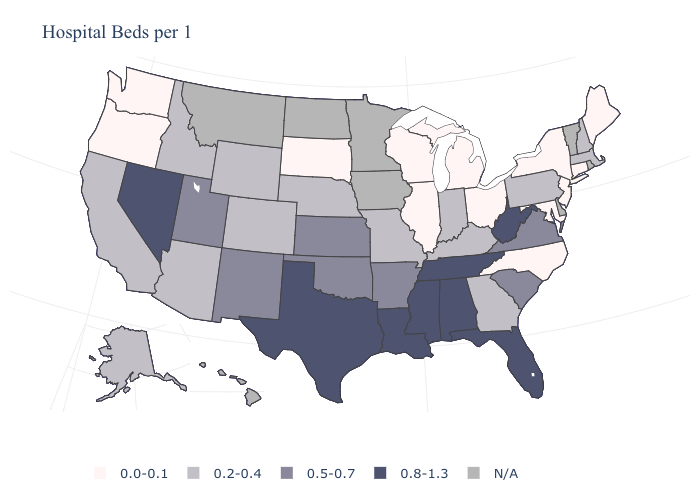What is the lowest value in the MidWest?
Keep it brief. 0.0-0.1. Name the states that have a value in the range 0.5-0.7?
Concise answer only. Arkansas, Kansas, New Mexico, Oklahoma, South Carolina, Utah, Virginia. What is the highest value in the MidWest ?
Write a very short answer. 0.5-0.7. Name the states that have a value in the range 0.0-0.1?
Give a very brief answer. Connecticut, Illinois, Maine, Maryland, Michigan, New Jersey, New York, North Carolina, Ohio, Oregon, South Dakota, Washington, Wisconsin. Which states hav the highest value in the South?
Keep it brief. Alabama, Florida, Louisiana, Mississippi, Tennessee, Texas, West Virginia. Which states have the highest value in the USA?
Short answer required. Alabama, Florida, Louisiana, Mississippi, Nevada, Tennessee, Texas, West Virginia. What is the value of Pennsylvania?
Concise answer only. 0.2-0.4. How many symbols are there in the legend?
Write a very short answer. 5. What is the value of Mississippi?
Keep it brief. 0.8-1.3. Name the states that have a value in the range 0.2-0.4?
Keep it brief. Alaska, Arizona, California, Colorado, Georgia, Idaho, Indiana, Kentucky, Massachusetts, Missouri, Nebraska, New Hampshire, Pennsylvania, Wyoming. Which states have the lowest value in the USA?
Keep it brief. Connecticut, Illinois, Maine, Maryland, Michigan, New Jersey, New York, North Carolina, Ohio, Oregon, South Dakota, Washington, Wisconsin. Name the states that have a value in the range 0.8-1.3?
Quick response, please. Alabama, Florida, Louisiana, Mississippi, Nevada, Tennessee, Texas, West Virginia. 